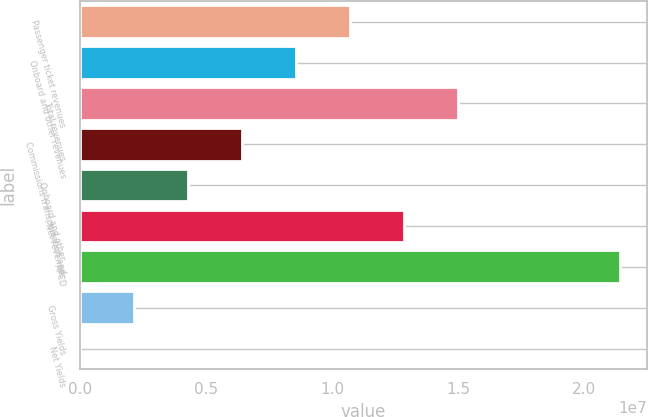<chart> <loc_0><loc_0><loc_500><loc_500><bar_chart><fcel>Passenger ticket revenues<fcel>Onboard and other revenues<fcel>Total revenues<fcel>Commissions transportation and<fcel>Onboard and other<fcel>Net revenues<fcel>APCD<fcel>Gross Yields<fcel>Net Yields<nl><fcel>1.07197e+07<fcel>8.57581e+06<fcel>1.50075e+07<fcel>6.4319e+06<fcel>4.28799e+06<fcel>1.28636e+07<fcel>2.14393e+07<fcel>2.14407e+06<fcel>160.1<nl></chart> 